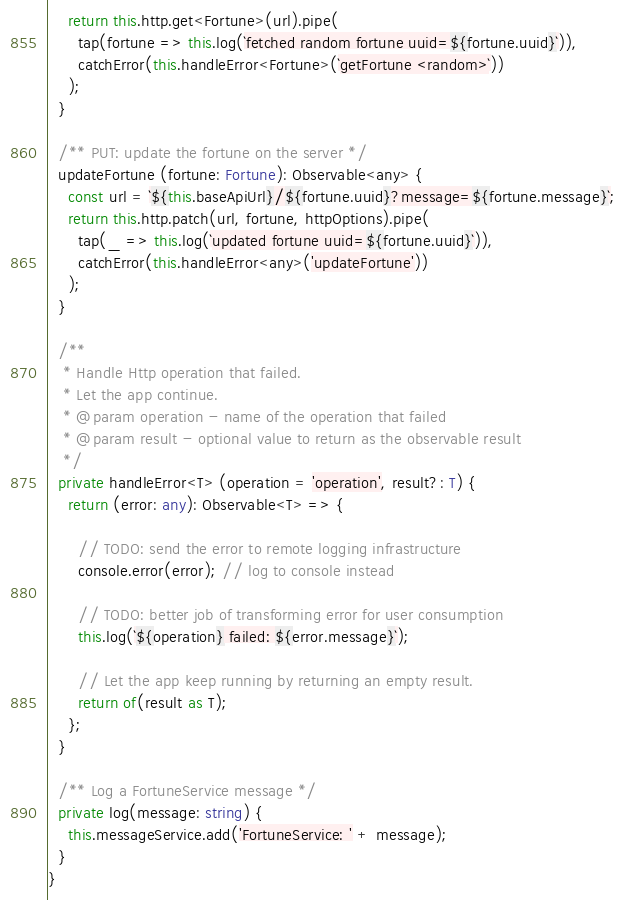Convert code to text. <code><loc_0><loc_0><loc_500><loc_500><_TypeScript_>    return this.http.get<Fortune>(url).pipe(
      tap(fortune => this.log(`fetched random fortune uuid=${fortune.uuid}`)),
      catchError(this.handleError<Fortune>(`getFortune <random>`))
    );
  }
  
  /** PUT: update the fortune on the server */
  updateFortune (fortune: Fortune): Observable<any> {
    const url = `${this.baseApiUrl}/${fortune.uuid}?message=${fortune.message}`;
    return this.http.patch(url, fortune, httpOptions).pipe(
      tap(_ => this.log(`updated fortune uuid=${fortune.uuid}`)),
      catchError(this.handleError<any>('updateFortune'))
    );
  }
  
  /**
   * Handle Http operation that failed.
   * Let the app continue.
   * @param operation - name of the operation that failed
   * @param result - optional value to return as the observable result
   */
  private handleError<T> (operation = 'operation', result?: T) {
    return (error: any): Observable<T> => {
      
      // TODO: send the error to remote logging infrastructure
      console.error(error); // log to console instead
      
      // TODO: better job of transforming error for user consumption
      this.log(`${operation} failed: ${error.message}`);
      
      // Let the app keep running by returning an empty result.
      return of(result as T);
    };
  }
  
  /** Log a FortuneService message */
  private log(message: string) {
    this.messageService.add('FortuneService: ' + message);
  }
}
</code> 